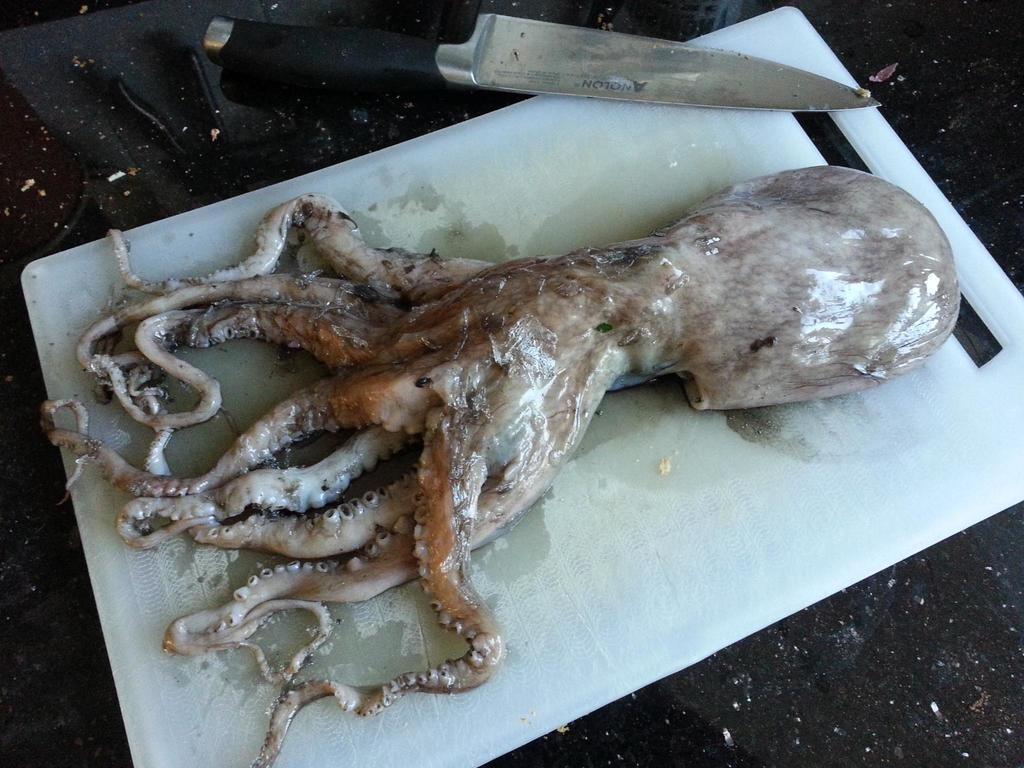What is the main subject of the image? There is an octopus on a chopping board in the image. Where is the chopping board located? The chopping board is on a table. What other object can be seen on the table in the image? There is a knife on the table in the image. What type of skirt is the octopus wearing in the image? There is no skirt present in the image, as the octopus is not wearing any clothing. 